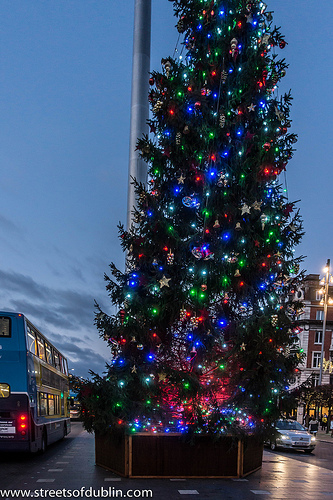<image>
Is the christmas tree next to the sidewalk? Yes. The christmas tree is positioned adjacent to the sidewalk, located nearby in the same general area. 